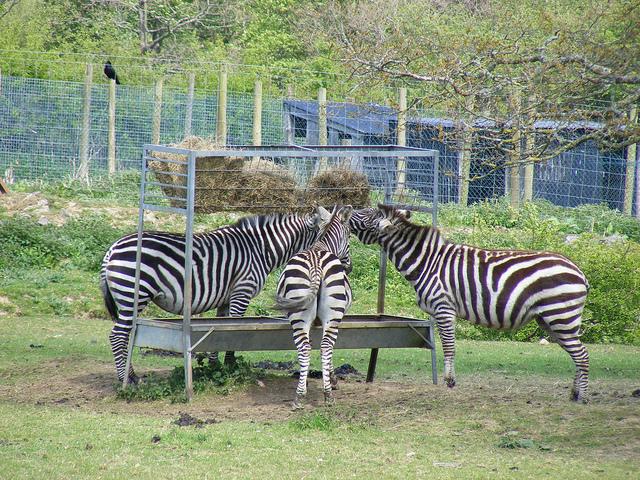Are the zebras in captivity?
Short answer required. Yes. How can you tell the animals are not allowed to roam?
Concise answer only. Fence. Can you see the zebras butt?
Answer briefly. Yes. How many animals in total?
Keep it brief. 3. What kind of animal is this?
Be succinct. Zebra. Are all the zebras feeding?
Answer briefly. Yes. What is the animal eating?
Concise answer only. Hay. 